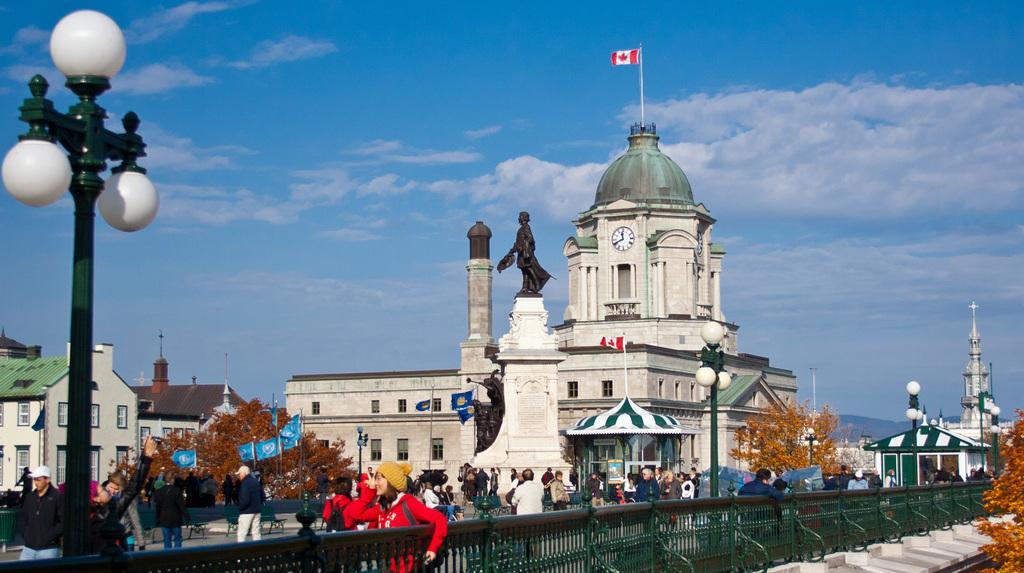In one or two sentences, can you explain what this image depicts? This image is taken outdoors. At the top of the image there is a sky with clouds. At the bottom of the image there is a railing. In the background there are a few houses and buildings. On the left side of the image there is a street light and a few people are standing on the road. In the middle of the image there is an architecture and there is a statue. There are a few stalls. Many people are walking on the road and a few are standing on the road. There are a few street lights and there are a few flags. 